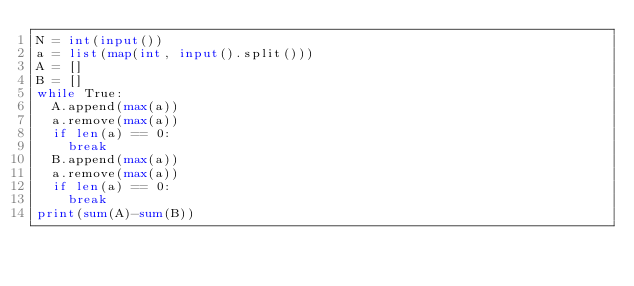Convert code to text. <code><loc_0><loc_0><loc_500><loc_500><_Python_>N = int(input())
a = list(map(int, input().split()))
A = []
B = []
while True:
  A.append(max(a))
  a.remove(max(a))
  if len(a) == 0:
    break
  B.append(max(a))
  a.remove(max(a))
  if len(a) == 0:
    break
print(sum(A)-sum(B))</code> 